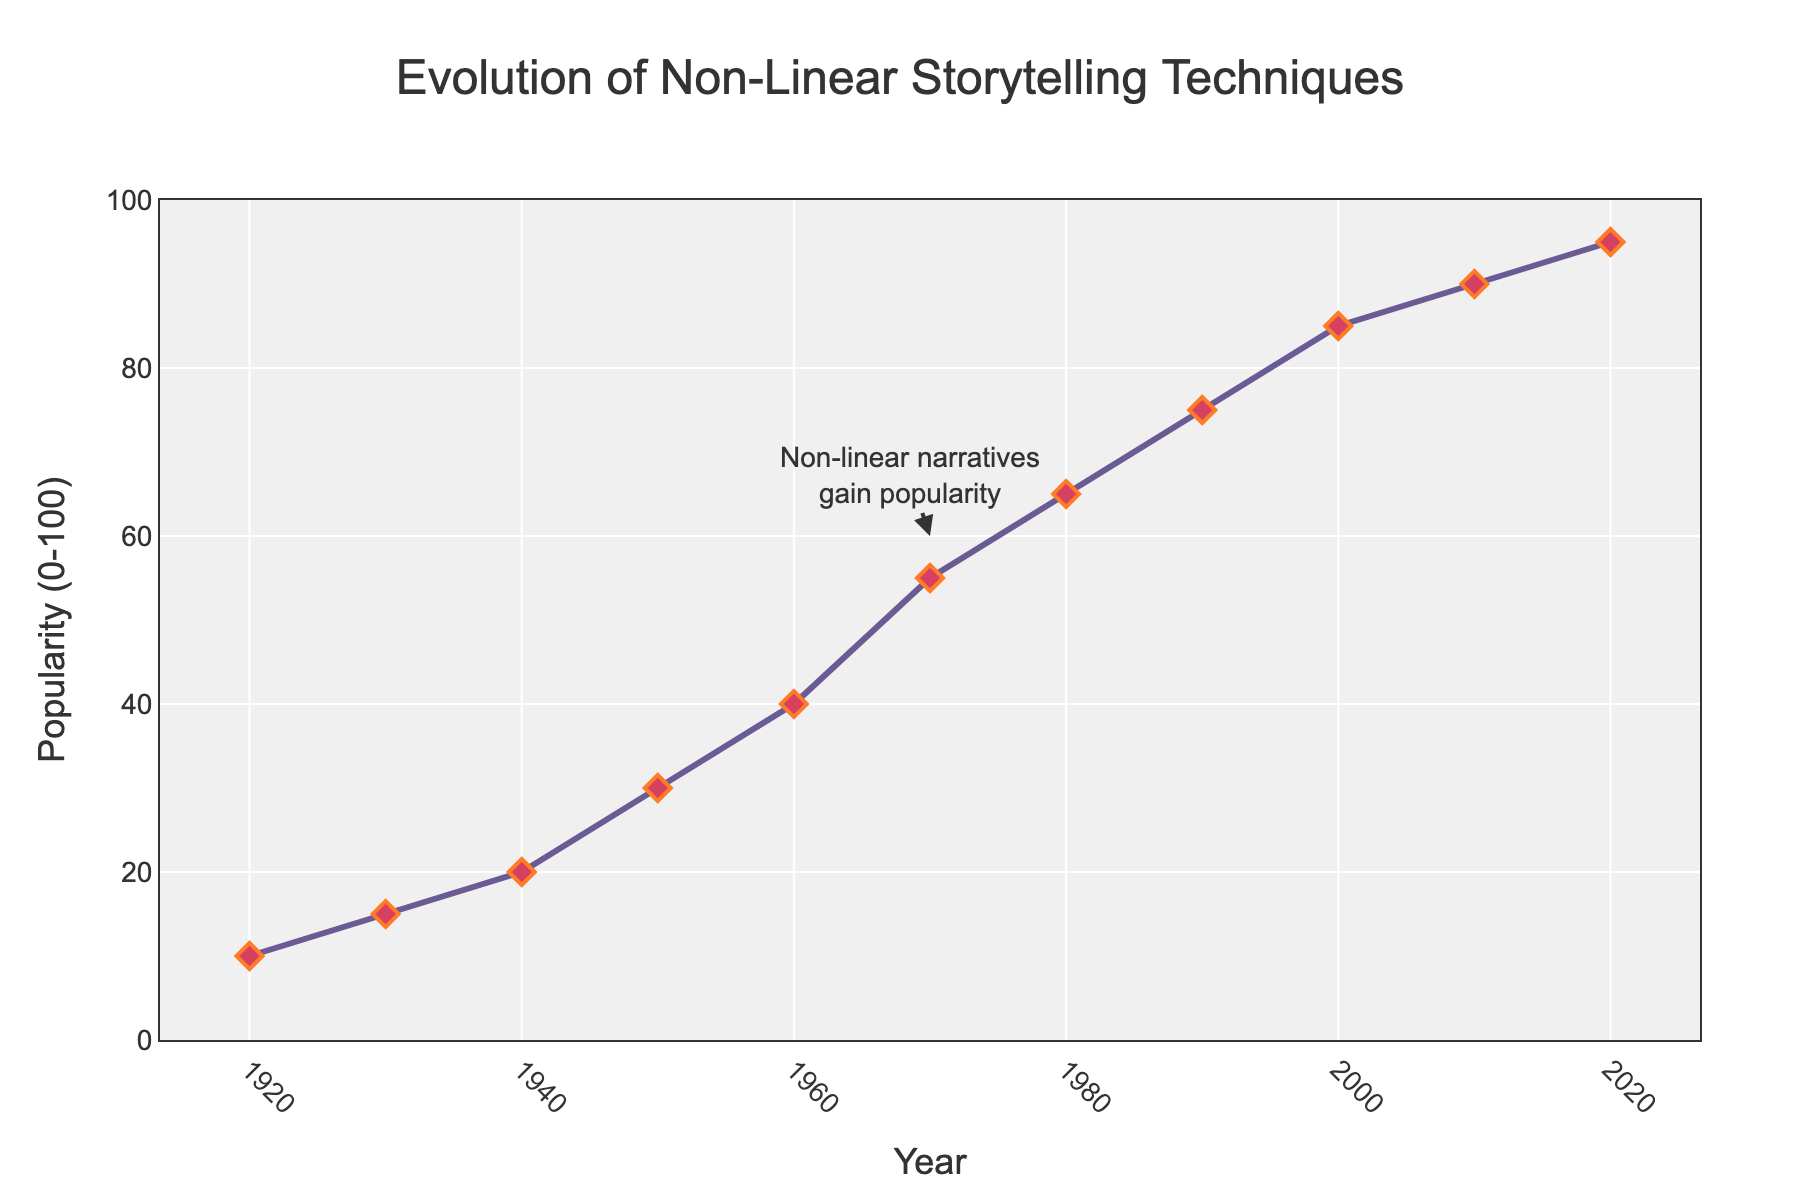What year did non-linear storytelling techniques see their first significant rise in popularity? The first significant rise in popularity is observed between 1930 and 1950, where the value jumped from 15 to 30.
Answer: 1950 In which decade did non-linear storytelling techniques see the highest rate of increase in popularity? The highest rate of increase can be observed from 1960 to 1970, where the popularity jumped from 40 to 55, an increase of 15 points.
Answer: 1960s How much did the popularity of non-linear storytelling techniques increase between 1950 and 1990? The popularity in 1950 was 30, and in 1990 it was 75. So the increase is 75 - 30.
Answer: 45 Compare the popularity index of non-linear storytelling techniques in 1940 with 2000. Which year had a higher value and by how much? In 1940, the value was 20. In 2000, the value was 85. The difference is 85 - 20.
Answer: 2000 by 65 What is the average popularity of non-linear storytelling techniques from 1920 to 2020? The sum of the values from 1920 to 2020 is (10 + 15 + 20 + 30 + 40 + 55 + 65 + 75 + 85 + 90 + 95) = 580. There are 11 data points, so the average is 580/11.
Answer: 52.73 Describe the change in the popularity of non-linear storytelling techniques from 1940 to 1960. In 1940, the popularity was 20. By 1960, it had increased to 40. This shows a doubling of the popularity over these two decades.
Answer: Doubled Which decade showed a marked increase relative to the previous one, the 1980s or the 2010s? The increase from 1980 to 1990 is from 65 to 75 (10 points), while the increase from 2010 to 2020 is from 90 to 95 (5 points). Therefore, the 1980s showed a greater increase relative to the previous decade.
Answer: 1980s How much did the popularity increase from 2010 to 2020? The popularity increased from 90 in 2010 to 95 in 2020. The difference is 95 - 90.
Answer: 5 What is the visual representation used to mark the data points in the line chart? The data points in the line chart are marked with red diamond shapes with a black outline.
Answer: Red diamonds 